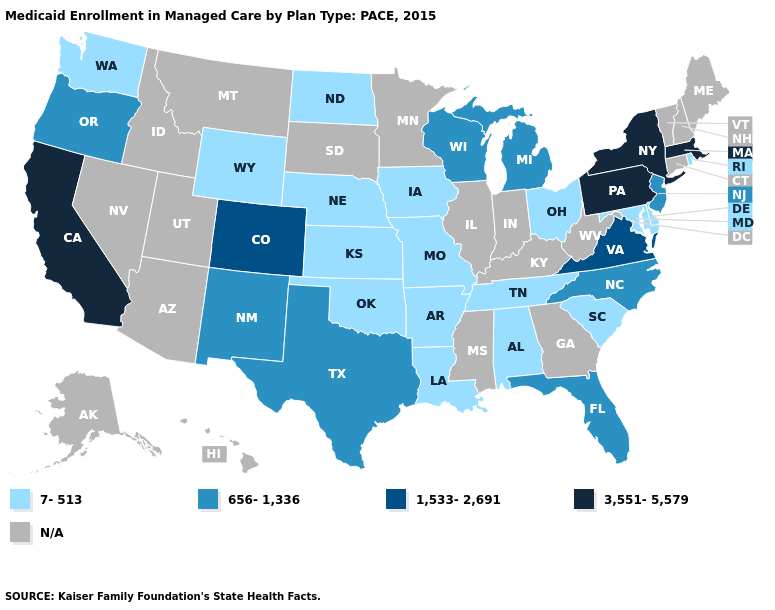What is the value of Virginia?
Write a very short answer. 1,533-2,691. Which states have the highest value in the USA?
Answer briefly. California, Massachusetts, New York, Pennsylvania. What is the value of Hawaii?
Answer briefly. N/A. What is the lowest value in states that border Iowa?
Keep it brief. 7-513. Name the states that have a value in the range 7-513?
Concise answer only. Alabama, Arkansas, Delaware, Iowa, Kansas, Louisiana, Maryland, Missouri, Nebraska, North Dakota, Ohio, Oklahoma, Rhode Island, South Carolina, Tennessee, Washington, Wyoming. Which states have the lowest value in the South?
Concise answer only. Alabama, Arkansas, Delaware, Louisiana, Maryland, Oklahoma, South Carolina, Tennessee. Name the states that have a value in the range N/A?
Be succinct. Alaska, Arizona, Connecticut, Georgia, Hawaii, Idaho, Illinois, Indiana, Kentucky, Maine, Minnesota, Mississippi, Montana, Nevada, New Hampshire, South Dakota, Utah, Vermont, West Virginia. Name the states that have a value in the range 7-513?
Quick response, please. Alabama, Arkansas, Delaware, Iowa, Kansas, Louisiana, Maryland, Missouri, Nebraska, North Dakota, Ohio, Oklahoma, Rhode Island, South Carolina, Tennessee, Washington, Wyoming. What is the lowest value in states that border Pennsylvania?
Concise answer only. 7-513. Among the states that border Minnesota , which have the lowest value?
Write a very short answer. Iowa, North Dakota. Does North Carolina have the lowest value in the South?
Be succinct. No. Which states have the lowest value in the USA?
Give a very brief answer. Alabama, Arkansas, Delaware, Iowa, Kansas, Louisiana, Maryland, Missouri, Nebraska, North Dakota, Ohio, Oklahoma, Rhode Island, South Carolina, Tennessee, Washington, Wyoming. What is the value of South Carolina?
Keep it brief. 7-513. Does the first symbol in the legend represent the smallest category?
Answer briefly. Yes. 